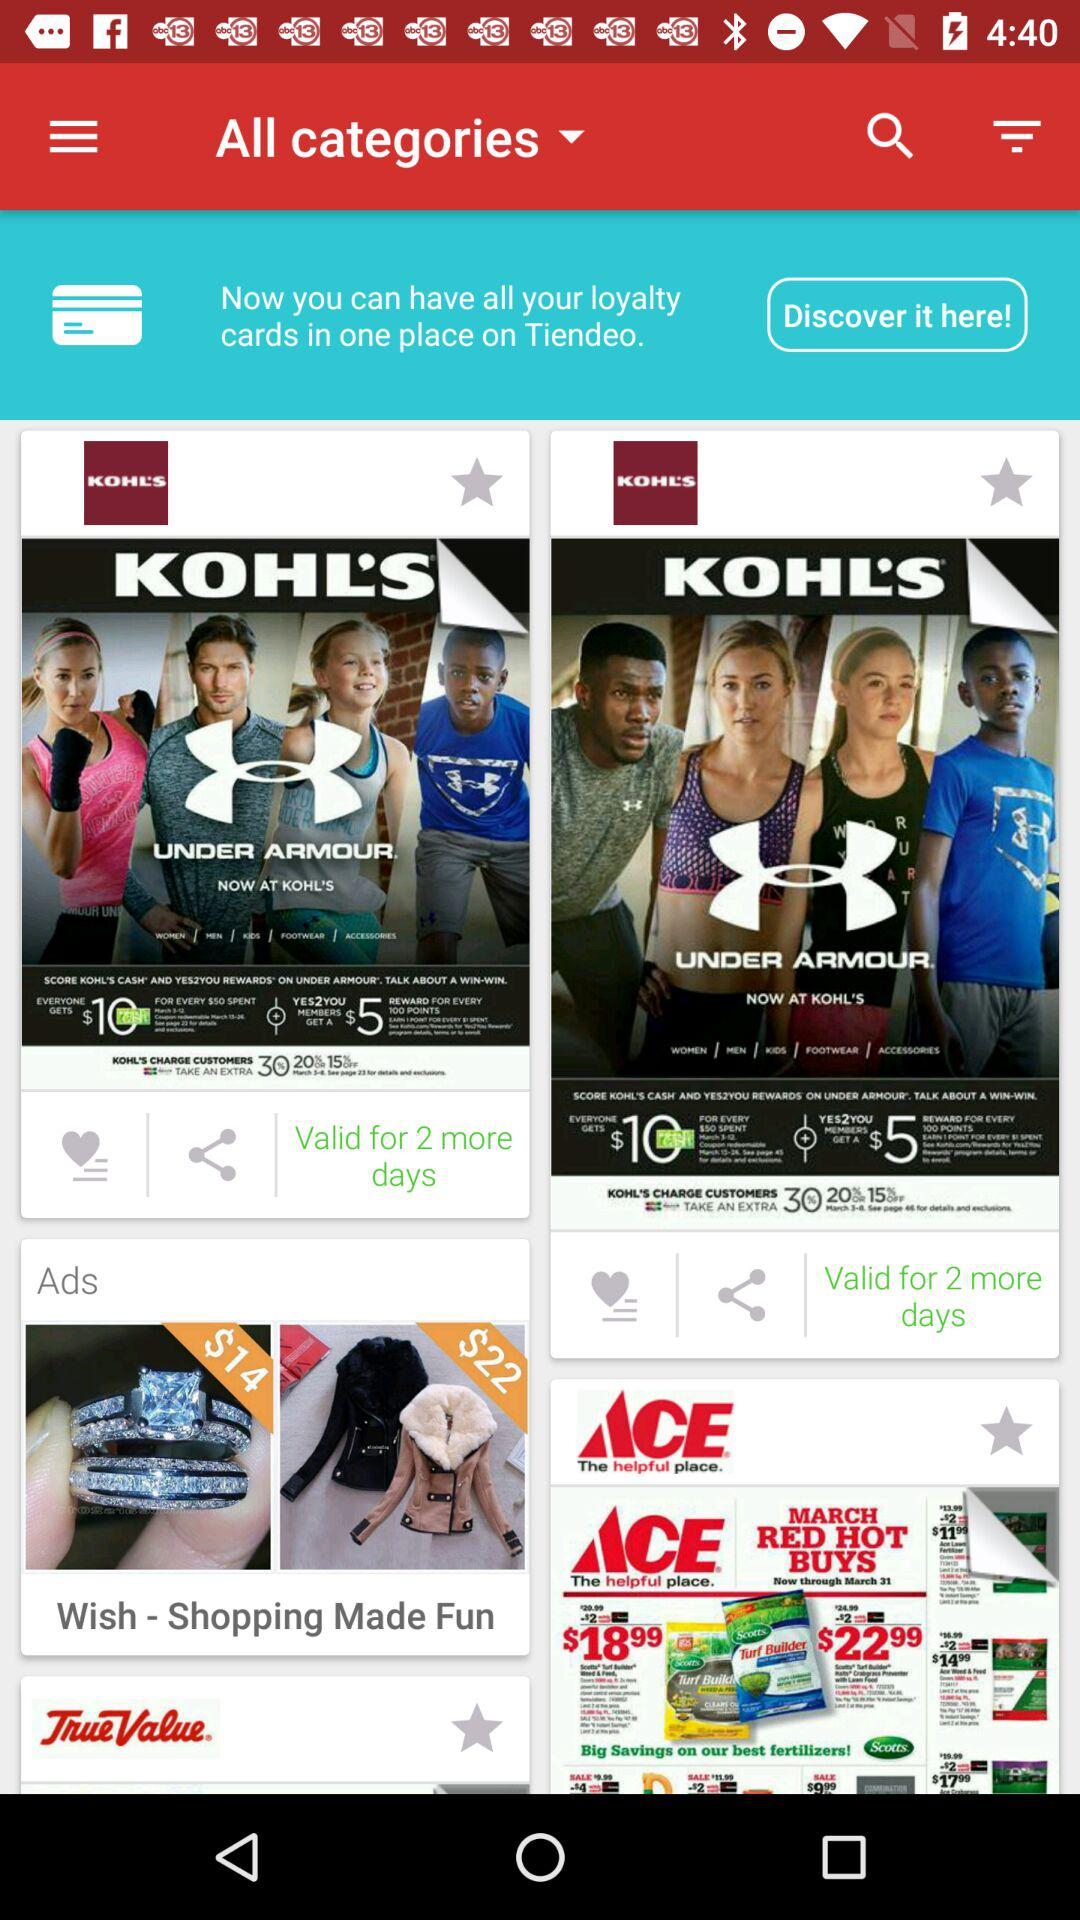What is the name of the brand in the advertisement? The name of the brand in the advertisement is "Wish". 